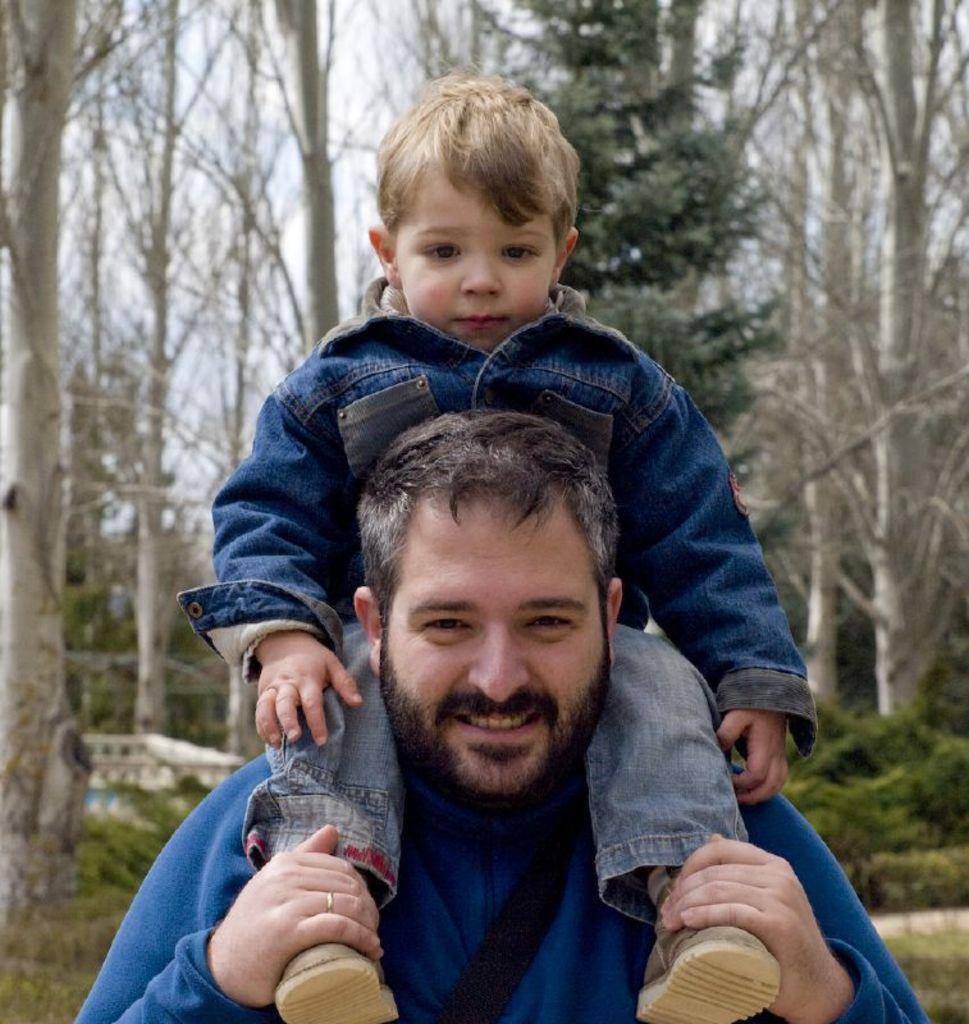Please provide a concise description of this image. In this picture there is a man in the center of the image and there is a small boy on his shoulders, there are trees in the background area of the image. 